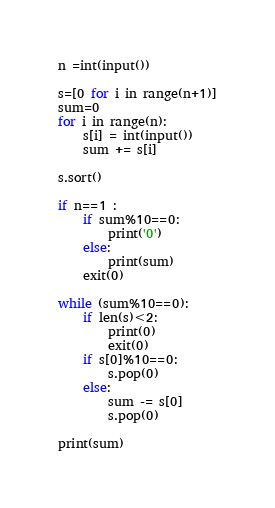<code> <loc_0><loc_0><loc_500><loc_500><_Python_>
n =int(input())

s=[0 for i in range(n+1)]
sum=0
for i in range(n):
	s[i] = int(input())
	sum += s[i]

s.sort()

if n==1 :
	if sum%10==0:
		print('0')
	else:
	    print(sum)
	exit(0)

while (sum%10==0):
	if len(s)<2:
		print(0)
		exit(0)
	if s[0]%10==0:
		s.pop(0)
	else:
		sum -= s[0]
		s.pop(0)

print(sum)
</code> 